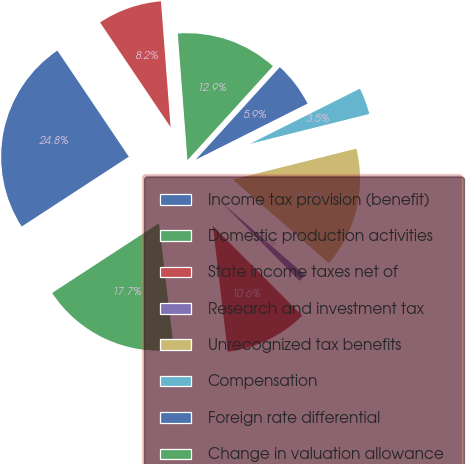<chart> <loc_0><loc_0><loc_500><loc_500><pie_chart><fcel>Income tax provision (benefit)<fcel>Domestic production activities<fcel>State income taxes net of<fcel>Research and investment tax<fcel>Unrecognized tax benefits<fcel>Compensation<fcel>Foreign rate differential<fcel>Change in valuation allowance<fcel>Other<nl><fcel>24.77%<fcel>17.68%<fcel>10.59%<fcel>1.13%<fcel>15.31%<fcel>3.5%<fcel>5.86%<fcel>12.95%<fcel>8.22%<nl></chart> 